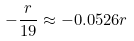<formula> <loc_0><loc_0><loc_500><loc_500>- \frac { r } { 1 9 } \approx - 0 . 0 5 2 6 r</formula> 